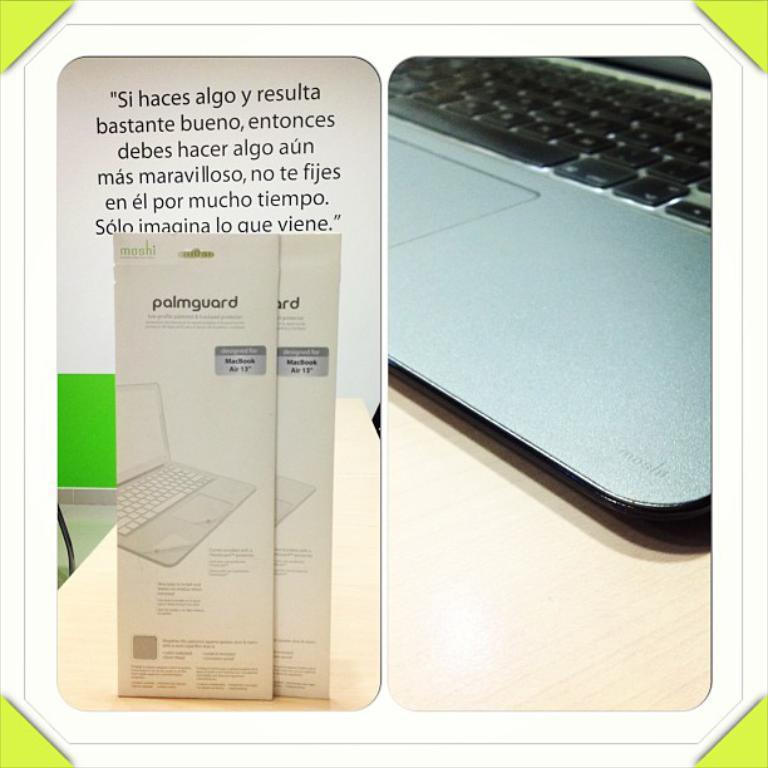<image>
Write a terse but informative summary of the picture. a mashi palmgaurd table that works with the macpro air 